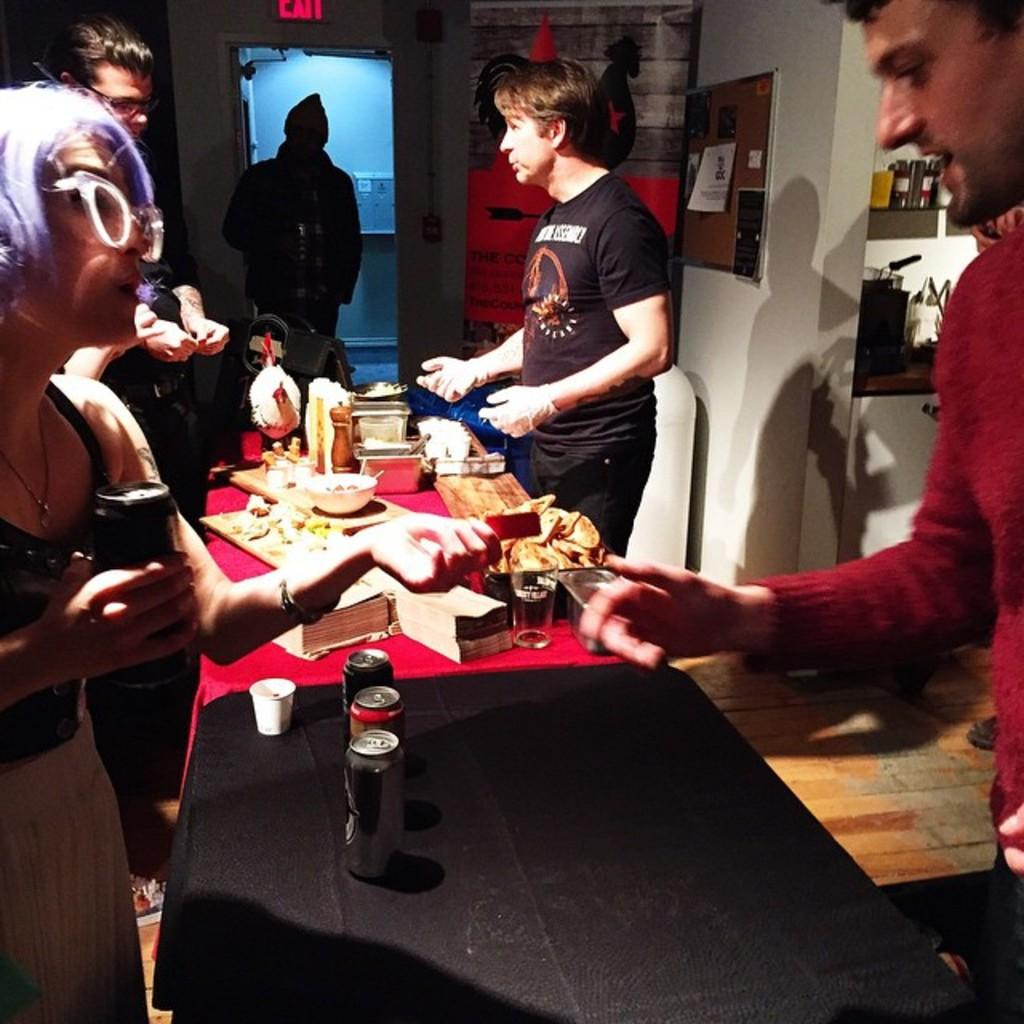What is on the table in the image? There is a bottle, a glass, food, a bowl, and a cup on the table in the image. Can you describe the person standing near the table? There is a person standing near the table, but their appearance or actions are not described in the facts. How many items can be seen on the table in the image? There are five items on the table in the image: a bottle, a glass, food, a bowl, and a cup. How many cats can be seen playing in the park in the image? There are no cats or park present in the image; it features a table with various items on it and a person standing near the table. What type of gun is visible on the table in the image? There is no gun present on the table in the image. 